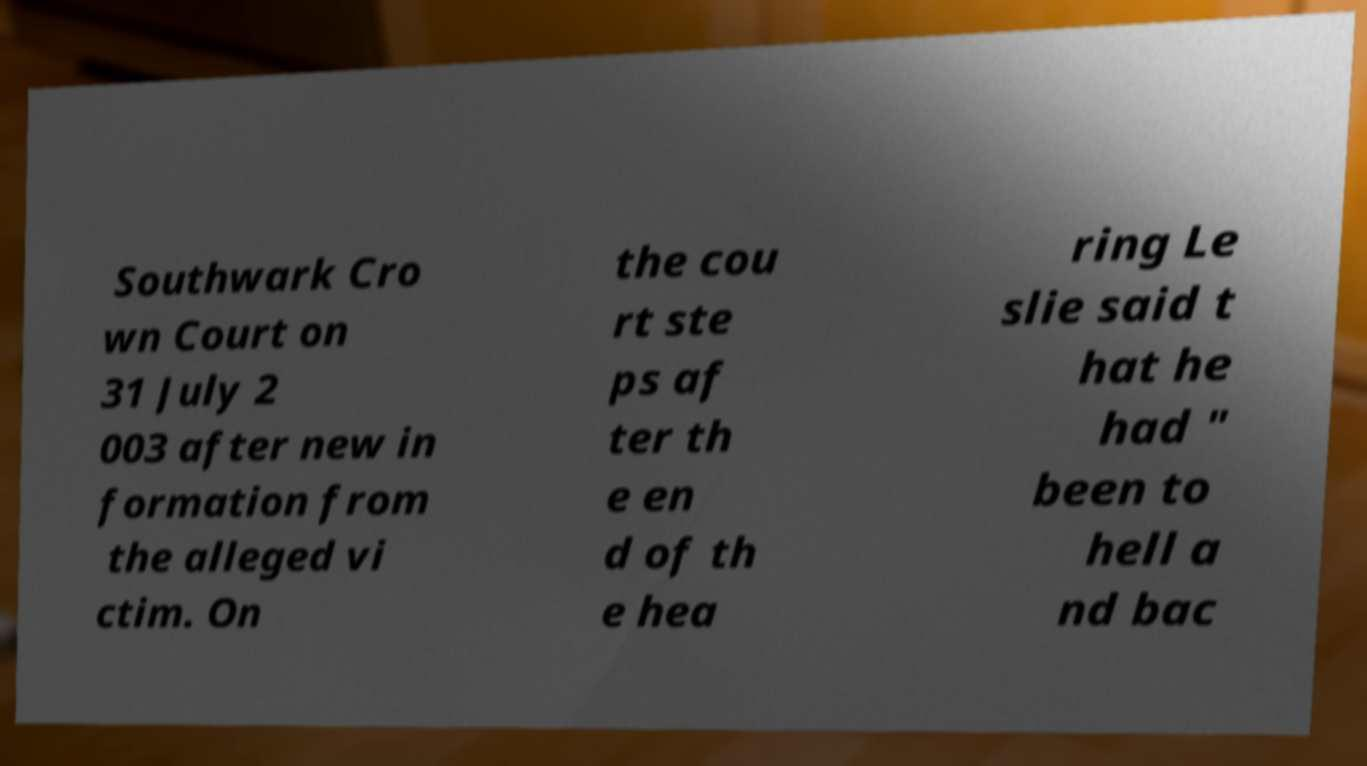For documentation purposes, I need the text within this image transcribed. Could you provide that? Southwark Cro wn Court on 31 July 2 003 after new in formation from the alleged vi ctim. On the cou rt ste ps af ter th e en d of th e hea ring Le slie said t hat he had " been to hell a nd bac 